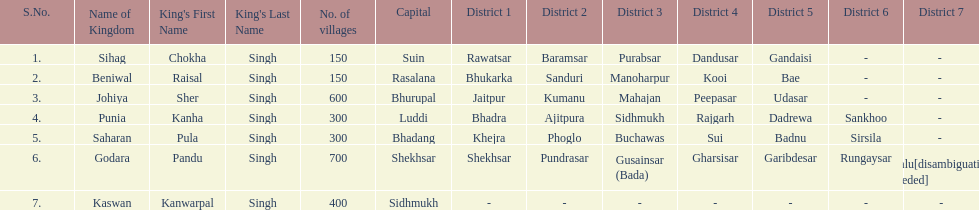Could you help me parse every detail presented in this table? {'header': ['S.No.', 'Name of Kingdom', "King's First Name", "King's Last Name", 'No. of villages', 'Capital', 'District 1', 'District 2', 'District 3', 'District 4', 'District 5', 'District 6', 'District 7'], 'rows': [['1.', 'Sihag', 'Chokha', 'Singh', '150', 'Suin', 'Rawatsar', 'Baramsar', 'Purabsar', 'Dandusar', 'Gandaisi', '-', '- '], ['2.', 'Beniwal', 'Raisal', 'Singh', '150', 'Rasalana', 'Bhukarka', 'Sanduri', 'Manoharpur', 'Kooi', 'Bae', '-', '- '], ['3.', 'Johiya', 'Sher', 'Singh', '600', 'Bhurupal', 'Jaitpur', 'Kumanu', 'Mahajan', 'Peepasar', 'Udasar', '-', '- '], ['4.', 'Punia', 'Kanha', 'Singh', '300', 'Luddi', 'Bhadra', 'Ajitpura', 'Sidhmukh', 'Rajgarh', 'Dadrewa', 'Sankhoo', '- '], ['5.', 'Saharan', 'Pula', 'Singh', '300', 'Bhadang', 'Khejra', 'Phoglo', 'Buchawas', 'Sui', 'Badnu', 'Sirsila', '- '], ['6.', 'Godara', 'Pandu', 'Singh', '700', 'Shekhsar', 'Shekhsar', 'Pundrasar', 'Gusainsar (Bada)', 'Gharsisar', 'Garibdesar', 'Rungaysar', 'Kalu[disambiguation needed]'], ['7.', 'Kaswan', 'Kanwarpal', 'Singh', '400', 'Sidhmukh', '-', '-', '-', '-', '-', '-', '-']]} What is the next kingdom listed after sihag? Beniwal. 